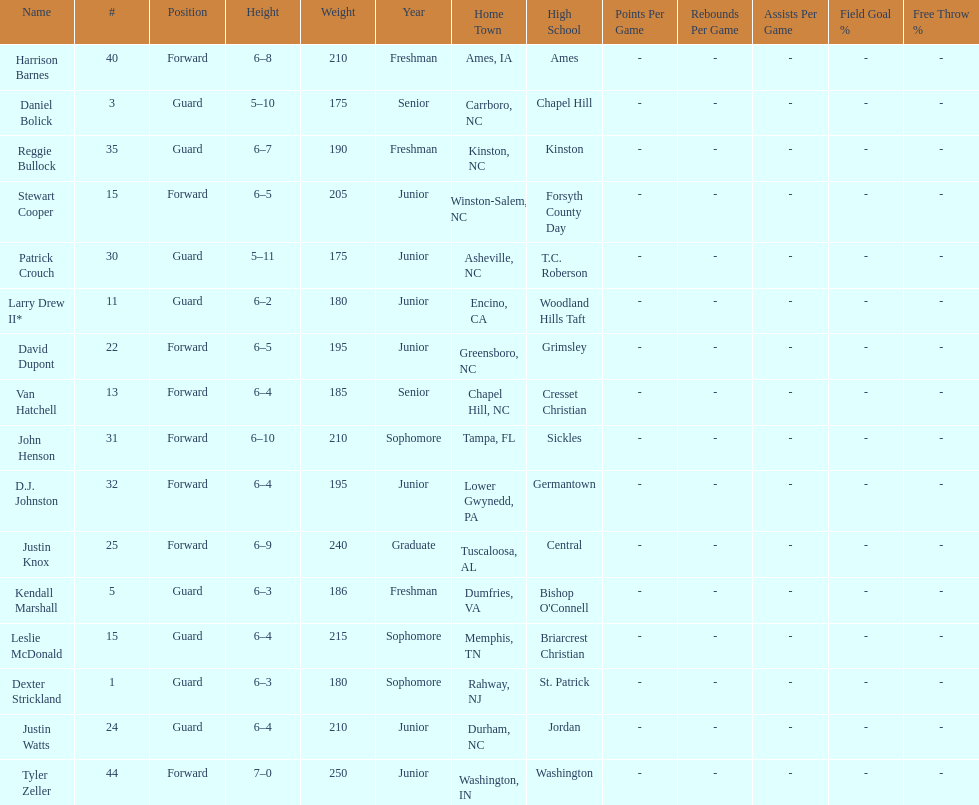What was the number of freshmen on the team? 3. 